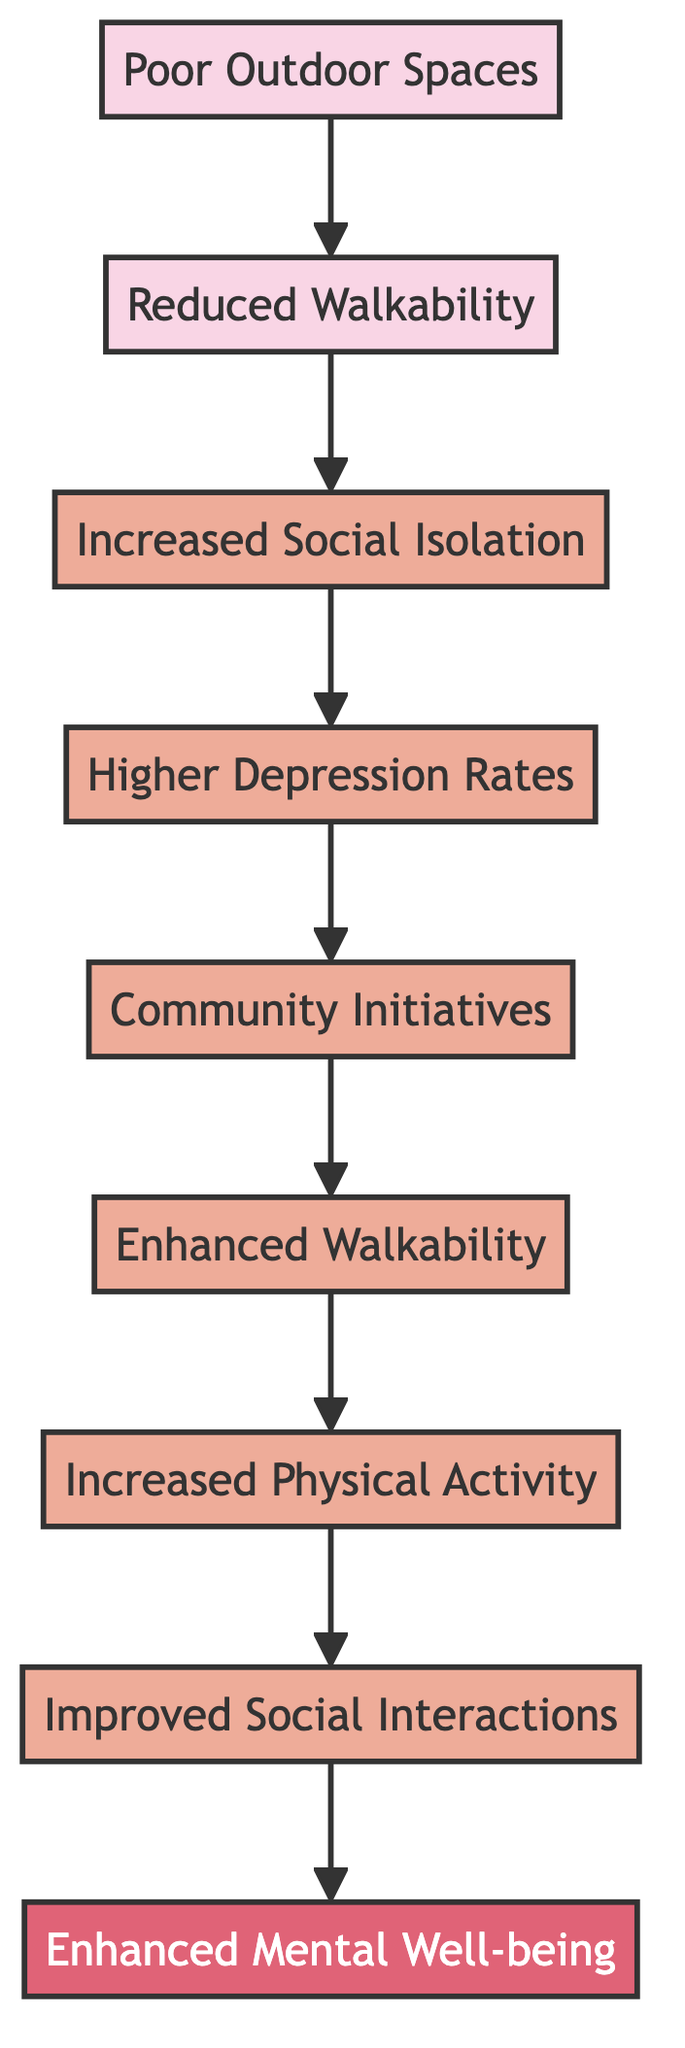What is at the base of the flow chart? The diagram starts with "Poor Outdoor Spaces," which is the foundational element in the flow from poor environments to improved mental well-being.
Answer: Poor Outdoor Spaces How many levels are in the diagram? The diagram has a total of eight levels, starting from "Poor Outdoor Spaces" at the base to "Enhanced Mental Well-being" at the top.
Answer: Eight What follows "Reduced Walkability"? According to the flow of the diagram, the next element after "Reduced Walkability" is "Increased Social Isolation."
Answer: Increased Social Isolation What is the relationship between "Community Initiatives" and "Higher Depression Rates"? "Community Initiatives" aims to improve conditions leading to reduced "Higher Depression Rates" by creating a better environment for mental health.
Answer: Improvement What is the final goal of the flow chart? The ultimate aim presented in the diagram is to achieve "Enhanced Mental Well-being," which encompasses lower depression rates and better mood overall.
Answer: Enhanced Mental Well-being How many connections lead from "Increased Physical Activity"? There is one connection leading from "Increased Physical Activity" to "Improved Social Interactions," indicating that increased activity promotes better social connections.
Answer: One What is the first step moving towards improved mental health? The first step indicated in the diagram that leads towards enhanced mental health is "Community Initiatives," which catalyze improvement in outdoor spaces.
Answer: Community Initiatives What improves as a result of "Enhanced Walkability"? The flow chart shows that "Enhanced Walkability" leads to "Increased Physical Activity," indicating a direct benefit from better walkability.
Answer: Increased Physical Activity 